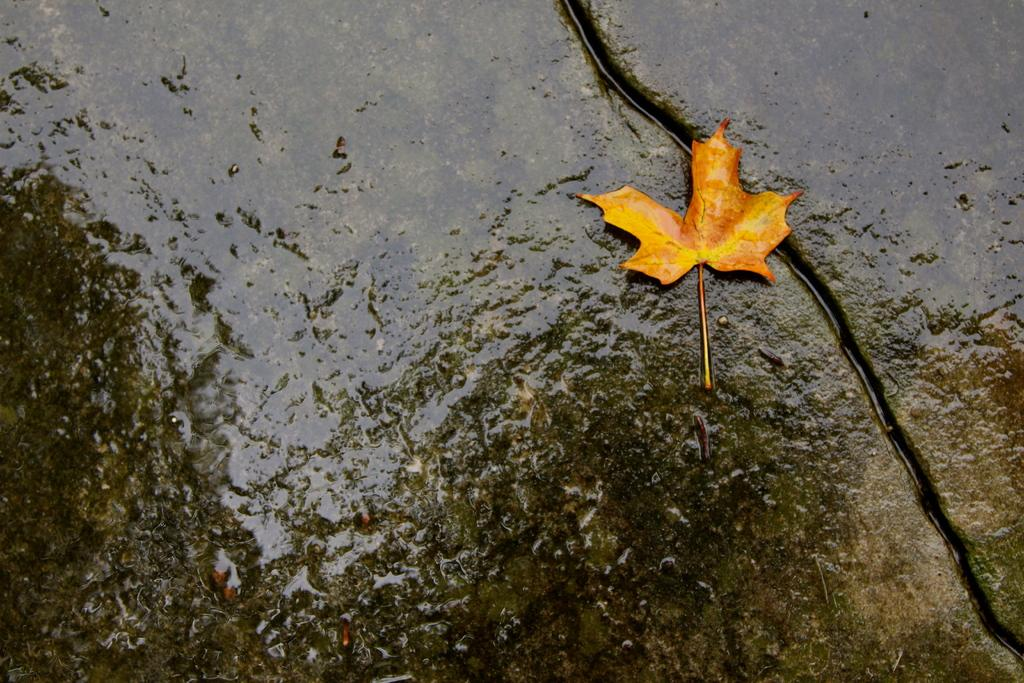What type of surface is visible in the image? There is a rocky surface in the image. What is present on the rocky surface? There is water on the rocky surface. What type of plant material can be seen in the image? There is a leaf in the image. What colors are present on the leaf? The leaf is yellow and orange in color. What type of historical event is taking place in the image? There is no historical event present in the image; it features a rocky surface, water, and a leaf. Can you tell me where the nearest hospital is in the image? There is no hospital present in the image; it features a rocky surface, water, and a leaf. 